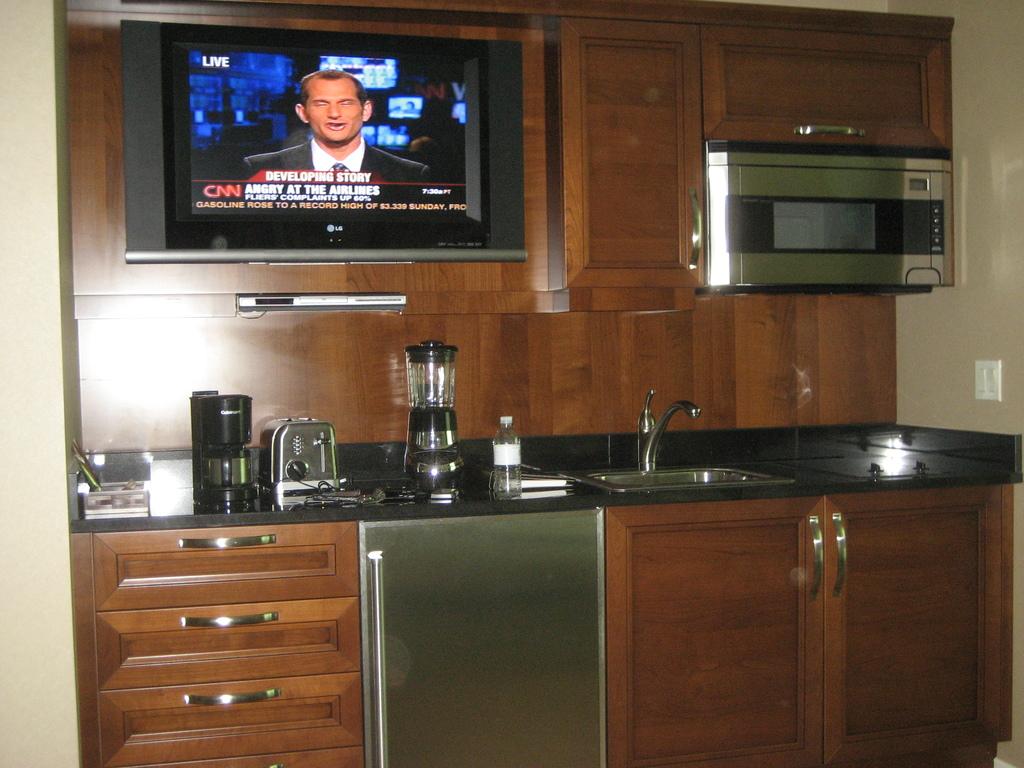What channel are they watching?
Give a very brief answer. Cnn. What brand of tv is that?
Your answer should be very brief. Lg. 